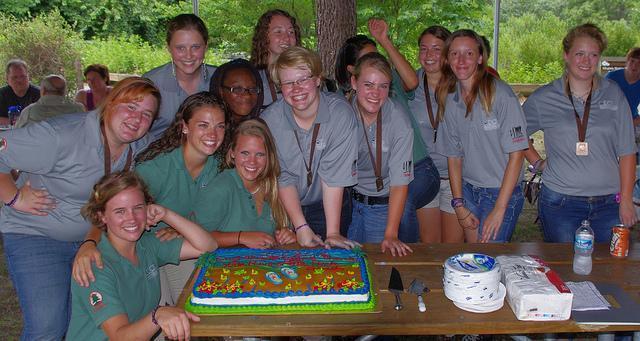How many people are there?
Give a very brief answer. 11. 